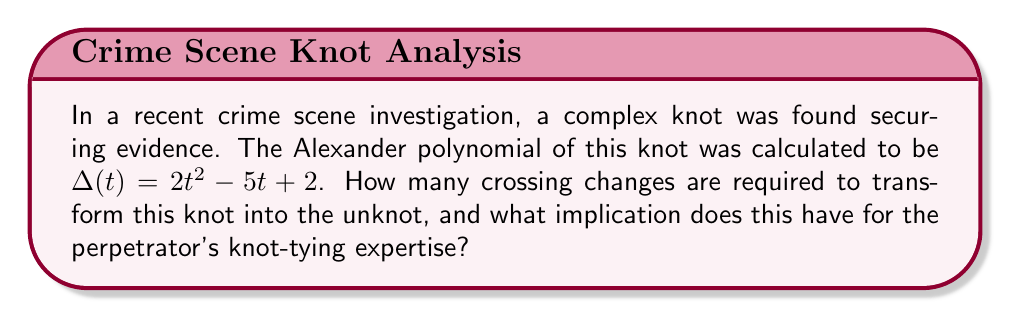Help me with this question. To solve this problem, we'll follow these steps:

1) Recall that the Alexander polynomial provides information about the complexity of a knot. The degree of the polynomial is related to the minimum number of crossing changes needed to unknot the knot.

2) The given Alexander polynomial is $\Delta(t) = 2t^2 - 5t + 2$

3) The degree of this polynomial is 2.

4) According to a theorem by Murasugi, the minimum number of crossing changes required to transform a knot into the unknot is less than or equal to half the degree of its Alexander polynomial.

5) Therefore, the maximum number of crossing changes needed is:
   $$\text{Max crossing changes} = \left\lfloor\frac{\text{degree}}{2}\right\rfloor = \left\lfloor\frac{2}{2}\right\rfloor = 1$$

6) This means that at most one crossing change is needed to transform this knot into the unknot.

7) Implication for the perpetrator's expertise: The low number of required crossing changes suggests that the knot, while appearing complex, is relatively simple in its fundamental structure. This could indicate that the perpetrator has some knowledge of knot-tying but may not be an expert, as a more complex knot would require more crossing changes to unknot.

8) For crime scene reconstruction, this information suggests that the knot could have been tied relatively quickly and without advanced knot-tying skills, which might help in profiling the perpetrator or understanding the time constraints of the crime.
Answer: 1 crossing change; suggests moderate knot-tying skill 